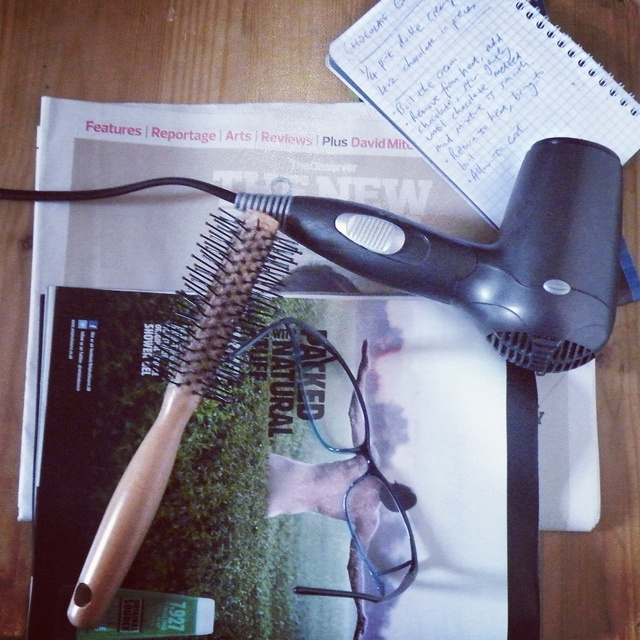Describe the objects in this image and their specific colors. I can see hair drier in maroon, purple, gray, and navy tones and people in maroon, darkgray, gray, and navy tones in this image. 